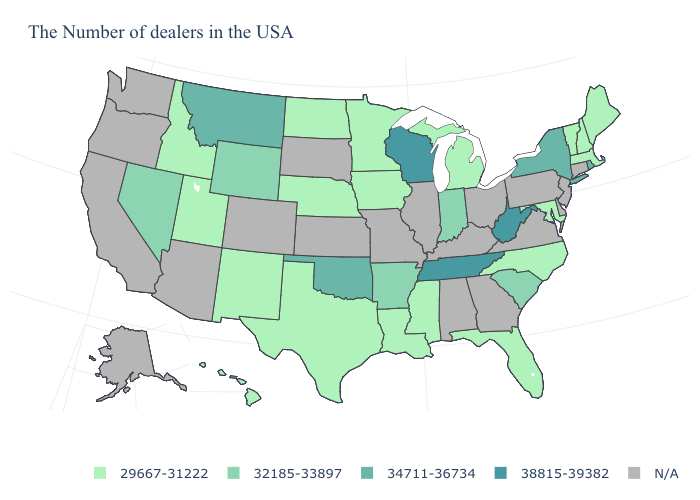What is the value of Nevada?
Quick response, please. 32185-33897. What is the value of Hawaii?
Short answer required. 29667-31222. What is the value of Tennessee?
Short answer required. 38815-39382. Name the states that have a value in the range 32185-33897?
Answer briefly. South Carolina, Indiana, Arkansas, Wyoming, Nevada. Name the states that have a value in the range N/A?
Short answer required. Connecticut, New Jersey, Delaware, Pennsylvania, Virginia, Ohio, Georgia, Kentucky, Alabama, Illinois, Missouri, Kansas, South Dakota, Colorado, Arizona, California, Washington, Oregon, Alaska. What is the lowest value in states that border Maine?
Quick response, please. 29667-31222. Does Nevada have the highest value in the West?
Write a very short answer. No. What is the lowest value in the Northeast?
Concise answer only. 29667-31222. Which states have the highest value in the USA?
Quick response, please. West Virginia, Tennessee, Wisconsin. Name the states that have a value in the range 34711-36734?
Quick response, please. Rhode Island, New York, Oklahoma, Montana. Name the states that have a value in the range N/A?
Concise answer only. Connecticut, New Jersey, Delaware, Pennsylvania, Virginia, Ohio, Georgia, Kentucky, Alabama, Illinois, Missouri, Kansas, South Dakota, Colorado, Arizona, California, Washington, Oregon, Alaska. Name the states that have a value in the range N/A?
Give a very brief answer. Connecticut, New Jersey, Delaware, Pennsylvania, Virginia, Ohio, Georgia, Kentucky, Alabama, Illinois, Missouri, Kansas, South Dakota, Colorado, Arizona, California, Washington, Oregon, Alaska. Among the states that border Kansas , which have the highest value?
Give a very brief answer. Oklahoma. What is the value of South Dakota?
Answer briefly. N/A. 